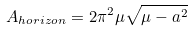<formula> <loc_0><loc_0><loc_500><loc_500>A _ { h o r i z o n } = { 2 \pi ^ { 2 } } \mu \sqrt { \mu - a ^ { 2 } }</formula> 